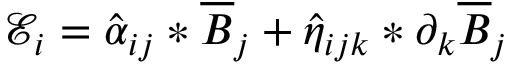<formula> <loc_0><loc_0><loc_500><loc_500>\mathcal { E } _ { i } = \hat { \alpha } _ { i j } \ast \overline { B } _ { j } + \hat { \eta } _ { i j k } * \partial _ { k } \overline { B } _ { j }</formula> 